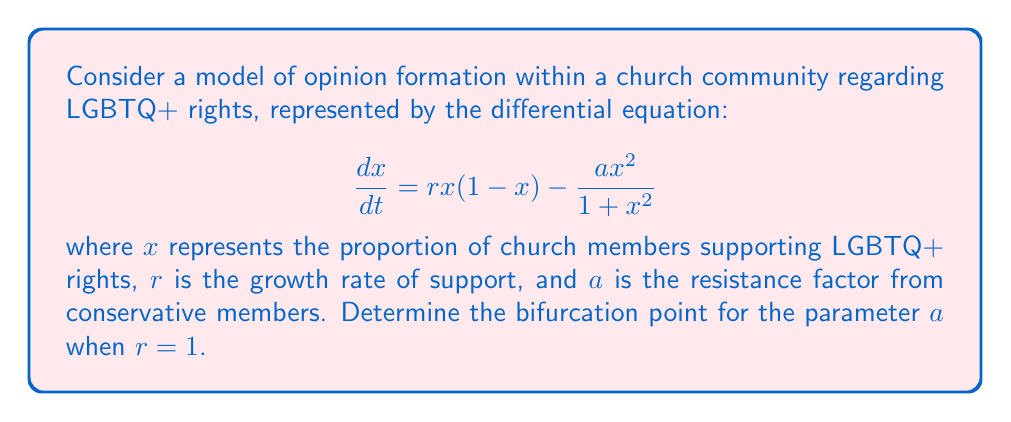Give your solution to this math problem. To find the bifurcation point, we need to follow these steps:

1) First, find the equilibrium points by setting $\frac{dx}{dt} = 0$:

   $$rx(1-x) - \frac{ax^2}{1+x^2} = 0$$

2) Substitute $r=1$:

   $$x(1-x) - \frac{ax^2}{1+x^2} = 0$$

3) Rearrange the equation:

   $$x(1-x)(1+x^2) = ax^2$$
   $$x + x^3 - x^2 - x^4 = ax^2$$
   $$x + x^3 - (a+1)x^2 - x^4 = 0$$

4) For a bifurcation point, this equation should have a double root. This occurs when both the function and its derivative are zero. Let's call the function $f(x)$:

   $$f(x) = x + x^3 - (a+1)x^2 - x^4$$

5) The derivative is:

   $$f'(x) = 1 + 3x^2 - 2(a+1)x - 4x^3$$

6) At the bifurcation point, both $f(x)$ and $f'(x)$ should be zero for some $x$. Due to the symmetry of the problem, this occurs at $x=\frac{1}{2}$. Substitute this into $f(x)=0$:

   $$\frac{1}{2} + \frac{1}{8} - (a+1)\frac{1}{4} - \frac{1}{16} = 0$$

7) Simplify and solve for $a$:

   $$\frac{8}{16} + \frac{2}{16} - (a+1)\frac{4}{16} - \frac{1}{16} = 0$$
   $$9 - 4(a+1) - 1 = 0$$
   $$8 - 4a - 4 = 0$$
   $$4 = 4a$$
   $$a = 1$$

Therefore, the bifurcation point occurs when $a=1$ for $r=1$.
Answer: $a=1$ 